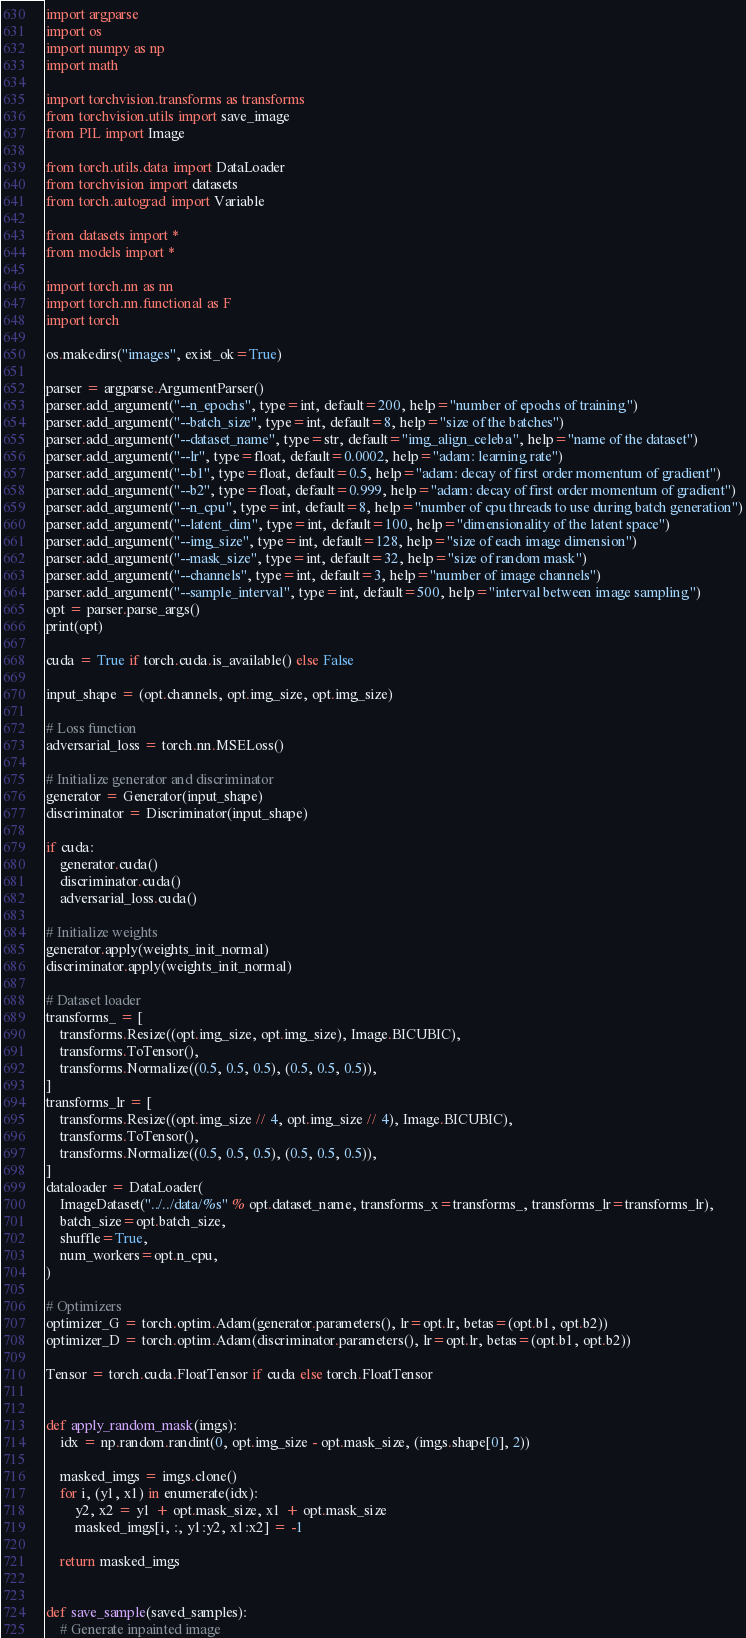Convert code to text. <code><loc_0><loc_0><loc_500><loc_500><_Python_>import argparse
import os
import numpy as np
import math

import torchvision.transforms as transforms
from torchvision.utils import save_image
from PIL import Image

from torch.utils.data import DataLoader
from torchvision import datasets
from torch.autograd import Variable

from datasets import *
from models import *

import torch.nn as nn
import torch.nn.functional as F
import torch

os.makedirs("images", exist_ok=True)

parser = argparse.ArgumentParser()
parser.add_argument("--n_epochs", type=int, default=200, help="number of epochs of training")
parser.add_argument("--batch_size", type=int, default=8, help="size of the batches")
parser.add_argument("--dataset_name", type=str, default="img_align_celeba", help="name of the dataset")
parser.add_argument("--lr", type=float, default=0.0002, help="adam: learning rate")
parser.add_argument("--b1", type=float, default=0.5, help="adam: decay of first order momentum of gradient")
parser.add_argument("--b2", type=float, default=0.999, help="adam: decay of first order momentum of gradient")
parser.add_argument("--n_cpu", type=int, default=8, help="number of cpu threads to use during batch generation")
parser.add_argument("--latent_dim", type=int, default=100, help="dimensionality of the latent space")
parser.add_argument("--img_size", type=int, default=128, help="size of each image dimension")
parser.add_argument("--mask_size", type=int, default=32, help="size of random mask")
parser.add_argument("--channels", type=int, default=3, help="number of image channels")
parser.add_argument("--sample_interval", type=int, default=500, help="interval between image sampling")
opt = parser.parse_args()
print(opt)

cuda = True if torch.cuda.is_available() else False

input_shape = (opt.channels, opt.img_size, opt.img_size)

# Loss function
adversarial_loss = torch.nn.MSELoss()

# Initialize generator and discriminator
generator = Generator(input_shape)
discriminator = Discriminator(input_shape)

if cuda:
    generator.cuda()
    discriminator.cuda()
    adversarial_loss.cuda()

# Initialize weights
generator.apply(weights_init_normal)
discriminator.apply(weights_init_normal)

# Dataset loader
transforms_ = [
    transforms.Resize((opt.img_size, opt.img_size), Image.BICUBIC),
    transforms.ToTensor(),
    transforms.Normalize((0.5, 0.5, 0.5), (0.5, 0.5, 0.5)),
]
transforms_lr = [
    transforms.Resize((opt.img_size // 4, opt.img_size // 4), Image.BICUBIC),
    transforms.ToTensor(),
    transforms.Normalize((0.5, 0.5, 0.5), (0.5, 0.5, 0.5)),
]
dataloader = DataLoader(
    ImageDataset("../../data/%s" % opt.dataset_name, transforms_x=transforms_, transforms_lr=transforms_lr),
    batch_size=opt.batch_size,
    shuffle=True,
    num_workers=opt.n_cpu,
)

# Optimizers
optimizer_G = torch.optim.Adam(generator.parameters(), lr=opt.lr, betas=(opt.b1, opt.b2))
optimizer_D = torch.optim.Adam(discriminator.parameters(), lr=opt.lr, betas=(opt.b1, opt.b2))

Tensor = torch.cuda.FloatTensor if cuda else torch.FloatTensor


def apply_random_mask(imgs):
    idx = np.random.randint(0, opt.img_size - opt.mask_size, (imgs.shape[0], 2))

    masked_imgs = imgs.clone()
    for i, (y1, x1) in enumerate(idx):
        y2, x2 = y1 + opt.mask_size, x1 + opt.mask_size
        masked_imgs[i, :, y1:y2, x1:x2] = -1

    return masked_imgs


def save_sample(saved_samples):
    # Generate inpainted image</code> 